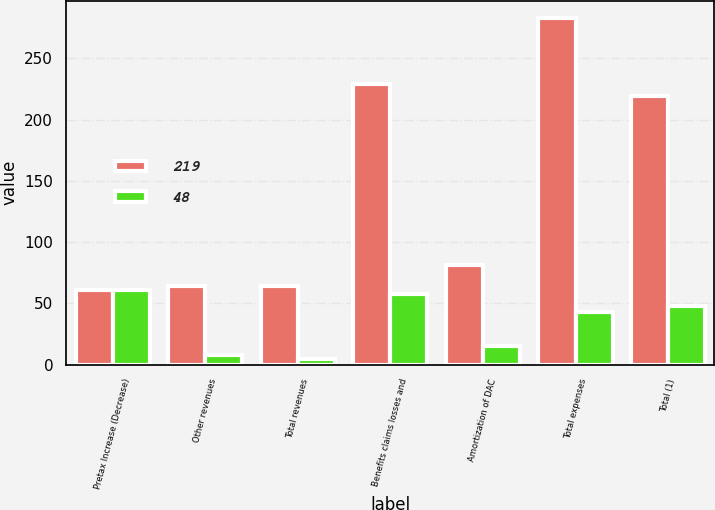Convert chart. <chart><loc_0><loc_0><loc_500><loc_500><stacked_bar_chart><ecel><fcel>Pretax Increase (Decrease)<fcel>Other revenues<fcel>Total revenues<fcel>Benefits claims losses and<fcel>Amortization of DAC<fcel>Total expenses<fcel>Total (1)<nl><fcel>219<fcel>61<fcel>64<fcel>64<fcel>229<fcel>81<fcel>283<fcel>219<nl><fcel>48<fcel>61<fcel>8<fcel>5<fcel>58<fcel>15<fcel>43<fcel>48<nl></chart> 